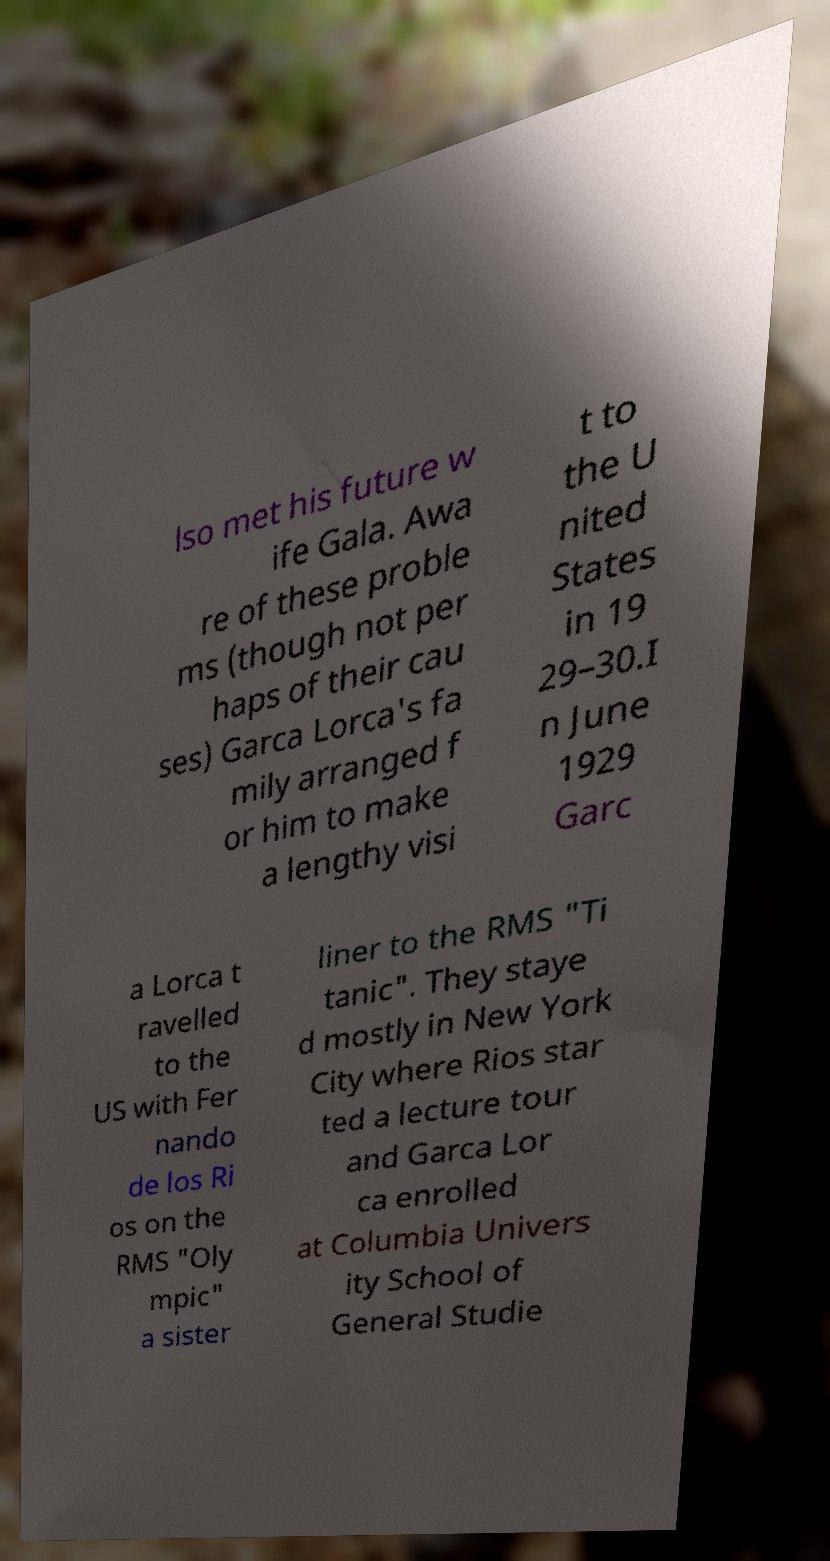Could you assist in decoding the text presented in this image and type it out clearly? lso met his future w ife Gala. Awa re of these proble ms (though not per haps of their cau ses) Garca Lorca's fa mily arranged f or him to make a lengthy visi t to the U nited States in 19 29–30.I n June 1929 Garc a Lorca t ravelled to the US with Fer nando de los Ri os on the RMS "Oly mpic" a sister liner to the RMS "Ti tanic". They staye d mostly in New York City where Rios star ted a lecture tour and Garca Lor ca enrolled at Columbia Univers ity School of General Studie 